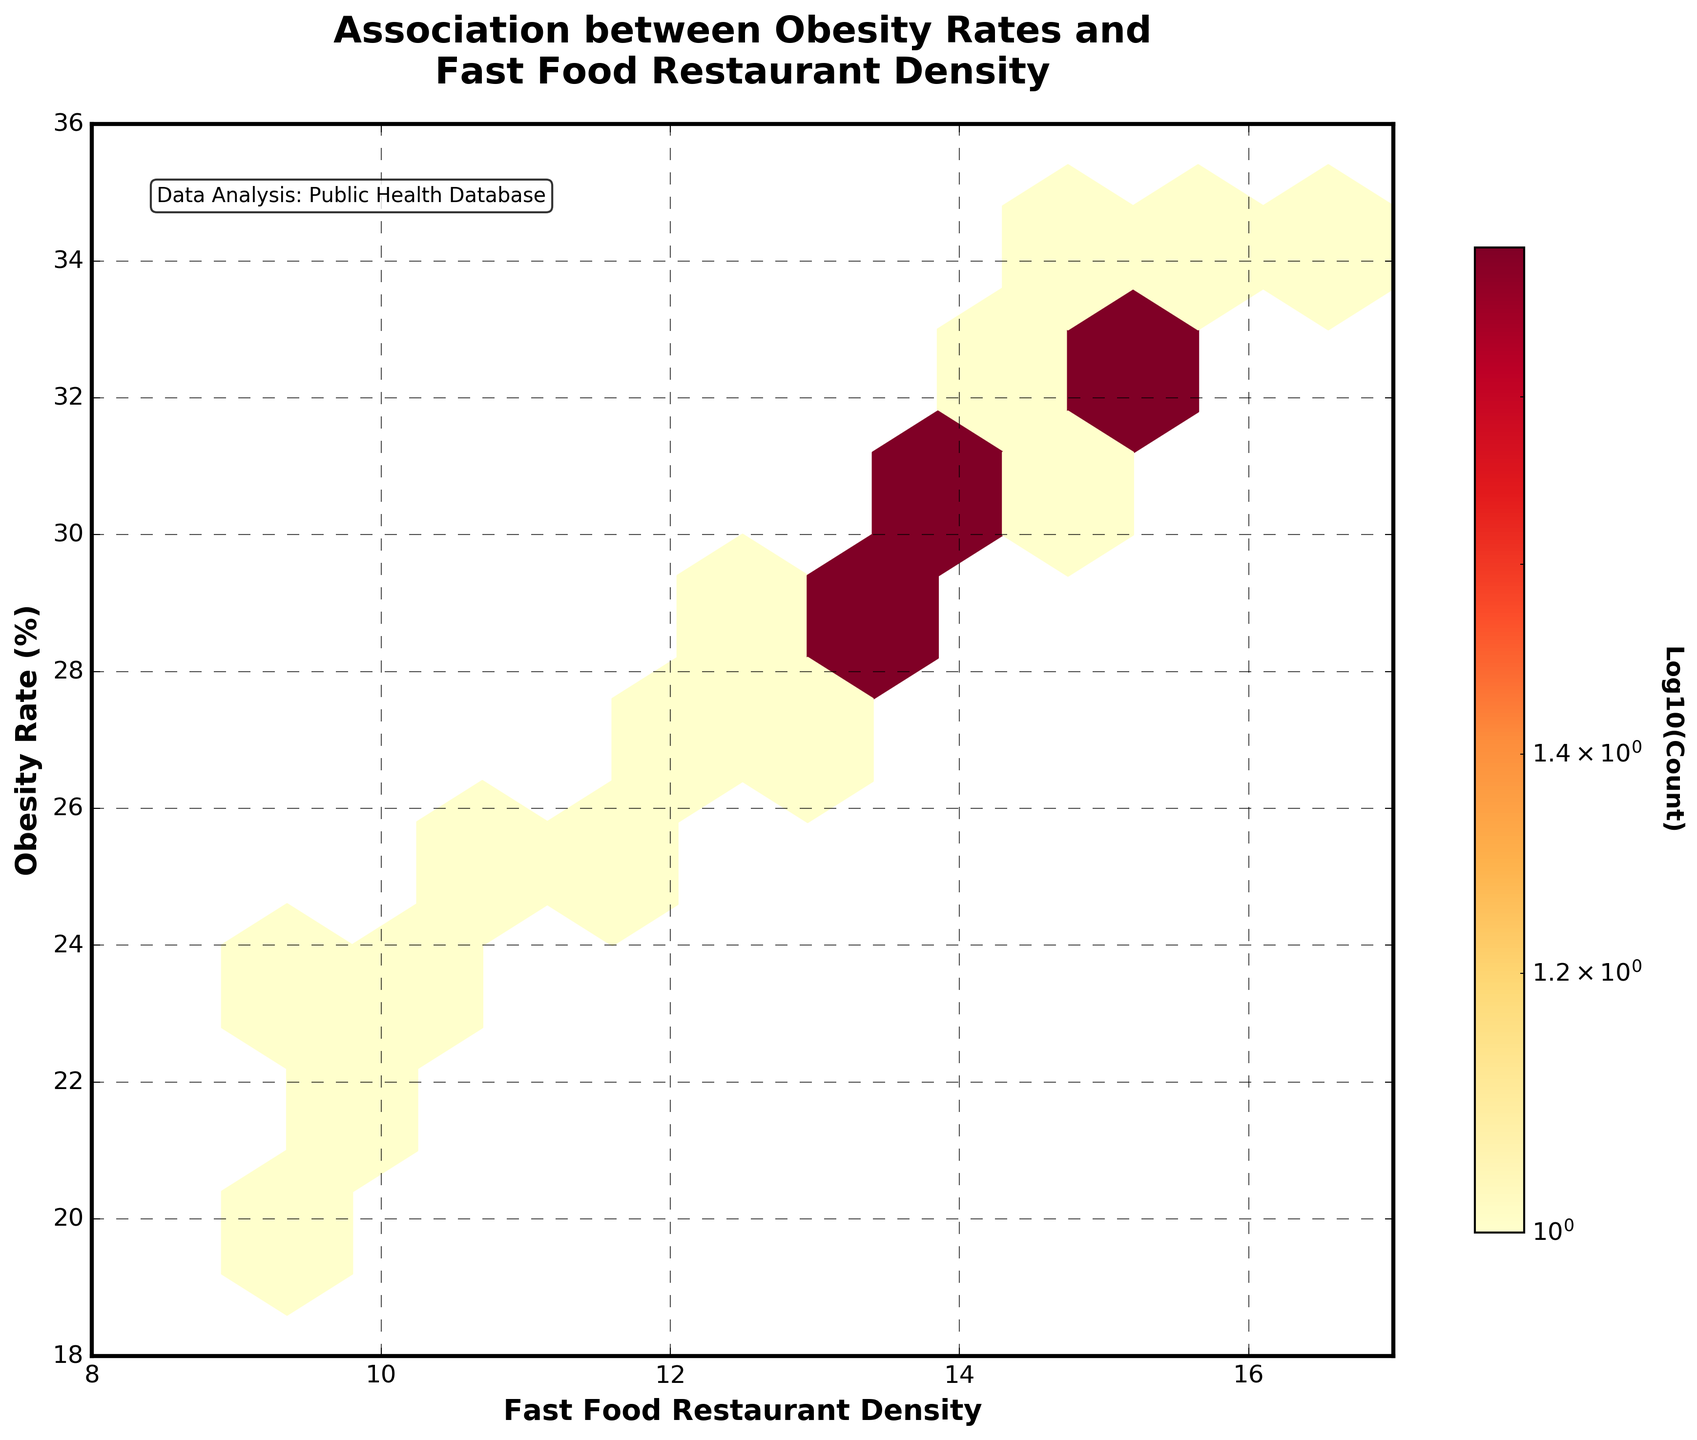What is the title of the hexbin plot? The title is located at the top center of the plot and reads "Association between Obesity Rates and Fast Food Restaurant Density."
Answer: "Association between Obesity Rates and Fast Food Restaurant Density" What does the color gradient represent in the plot? The color gradient from light yellow to dark red represents the log10(count) of data points falling within each hexagonal bin. Lighter colors indicate fewer data points, while darker colors indicate more data points.
Answer: Log10(Count) What are the labels of the x-axis and y-axis? The x-axis is labeled "Fast Food Restaurant Density," and the y-axis is labeled "Obesity Rate (%)". These labels are found below and to the left of the axes, respectively.
Answer: Fast Food Restaurant Density, Obesity Rate (%) Are there any data points with an obesity rate below 20%? To determine this, we look at the y-axis, which represents the obesity rate, and note that the data points only start at 19.7% and go up from there.
Answer: Yes What's the general association between fast food density and obesity rates based on the hexbin plot? By observing the overall trend of the bins, we can see that there is a tendency for areas with higher fast food density to have higher obesity rates, indicated by the concentration and color of the hexagons moving upwards diagonally.
Answer: Positive association Which data point shows the highest obesity rate, and how can you identify it? The point with the highest obesity rate can be identified as the hexbin that extends to the uppermost part of the y-axis (36) and largest x-axis (fast food density of 16.3). Since it is the data point for OKC, it indicates the highest value.
Answer: 34.5% obesity rate What is the density of fast food restaurants in neighborhoods where the obesity rate is less than 25%? We need to focus on the lower part of the hexbin plot, where the y-axis value is below 25%. Here, most density values of fast food restaurants are between 8 and 11.5.
Answer: 8 - 11.5 Compare the obesity rate in areas with fast food densities of 10 versus 15. We observe the color and position of the hexagons around these values. Fast food densities around 10 typically align with lower-to-mid-range obesity rates, while densities around 15 correlate with higher rates in the plot.
Answer: Higher at 15 density What does the color bar indicate in the plot? The color bar on the right side of the plot indicates the log10(count) of the data points, allowing viewers to understand the density of the data within the hexagonal bins.
Answer: Log10(Count) How does the grid size affect the hexbin plot visualization? The grid size affects the resolution of the hexbin plot; a smaller grid size would show more detail, while a larger grid size, like the one used, provides an aggregated visual summary of the association between variables.
Answer: It aggregates data What is the lowest obesity rate observed on this plot? By examining the y-axis, we can see the lowest value present for "Obesity Rate (%)" is around 19.7%.
Answer: 19.7% 